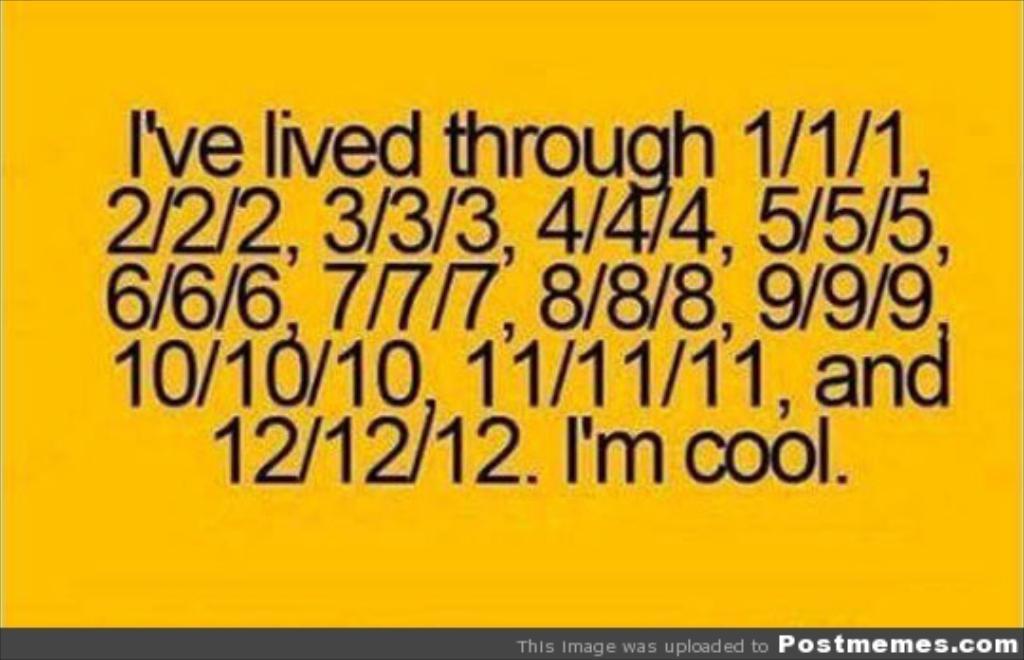Please provide a concise description of this image. The picture consists of text and numbers. The picture has yellow surface. 